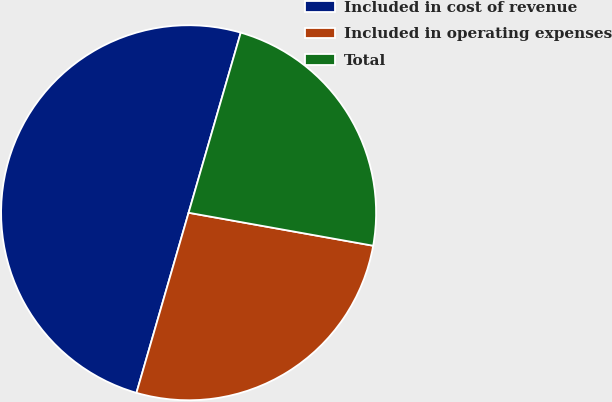<chart> <loc_0><loc_0><loc_500><loc_500><pie_chart><fcel>Included in cost of revenue<fcel>Included in operating expenses<fcel>Total<nl><fcel>50.0%<fcel>26.67%<fcel>23.33%<nl></chart> 